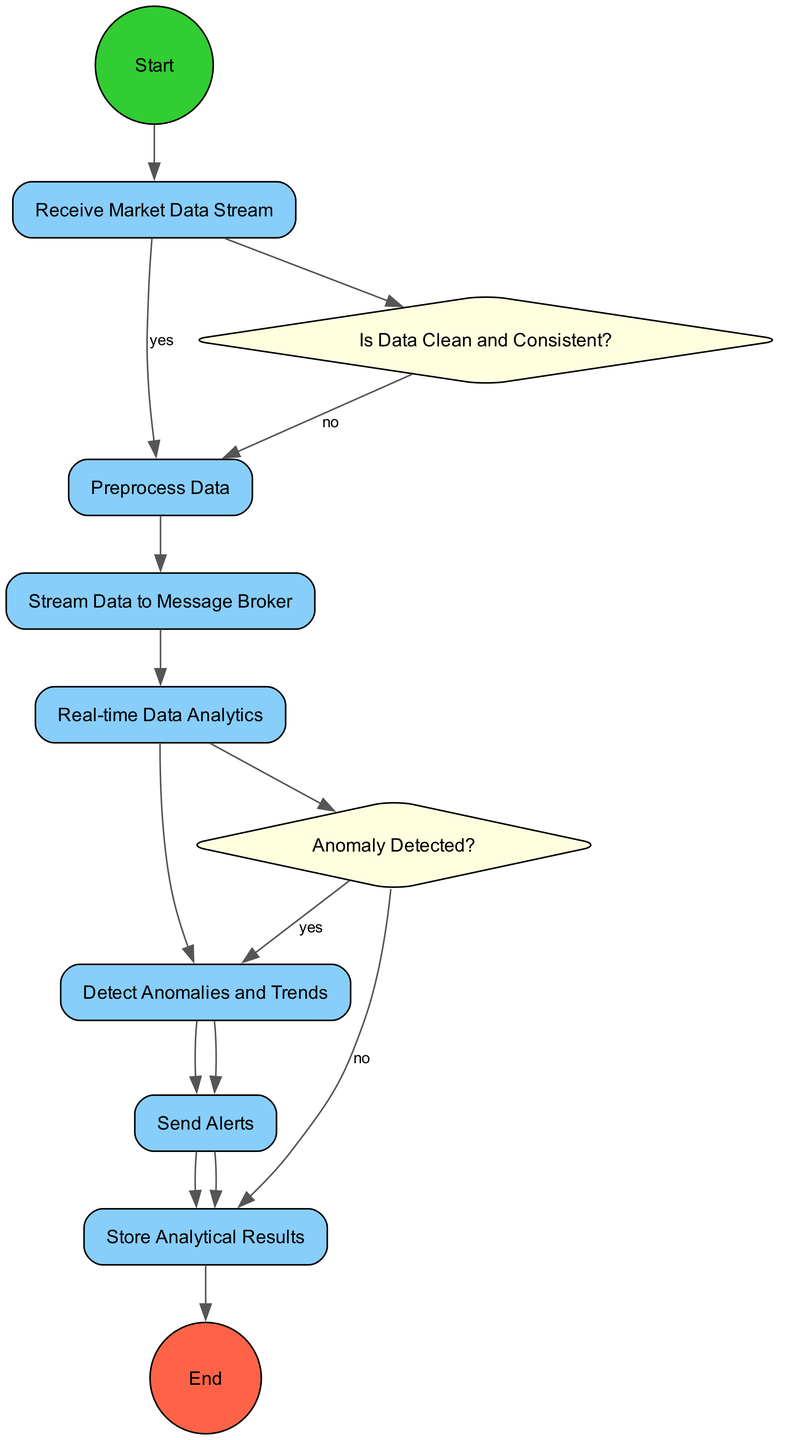What is the starting activity in the diagram? The starting activity is labeled as "Start," which is represented by a circular node at the beginning of the flow.
Answer: Start How many activities are represented in the diagram? There are seven activities listed in the diagram, each associated with a specific task in the real-time data pipeline.
Answer: Seven What is the first decision point presented in the diagram? The first decision point is labeled "Is Data Clean and Consistent?" and connects the first activity to the second activity based on whether the data is clean or not.
Answer: Is Data Clean and Consistent? What happens if the data is not clean? If the data is not clean, the flow goes from the decision node "Is Data Clean and Consistent?" back to the second activity "Preprocess Data," indicating the need for further preprocessing.
Answer: Preprocess Data How many outcomes are there for the second decision point? The second decision point, "Anomaly Detected?", has two outcomes: "yes" leads to the "Detect Anomalies and Trends" activity, and "no" leads to the "Store Analytical Results" activity.
Answer: Two Which activity follows the "Detect Anomalies and Trends" activity? The activity that follows "Detect Anomalies and Trends" is "Send Alerts," as indicated by the directed edge connecting these two activities.
Answer: Send Alerts From which activity does the "Store Analytical Results" derive? The "Store Analytical Results" activity directly follows the "Preprocess Data" activity if the earlier decision point indicates that the data and analytics processes do not detect anomalies.
Answer: Preprocess Data Which end state is shown at the conclusion of the diagram? The end state is labeled "End," represented by a circular shape colored tomato, indicating the completion of the flow after the analytical results are stored.
Answer: End 